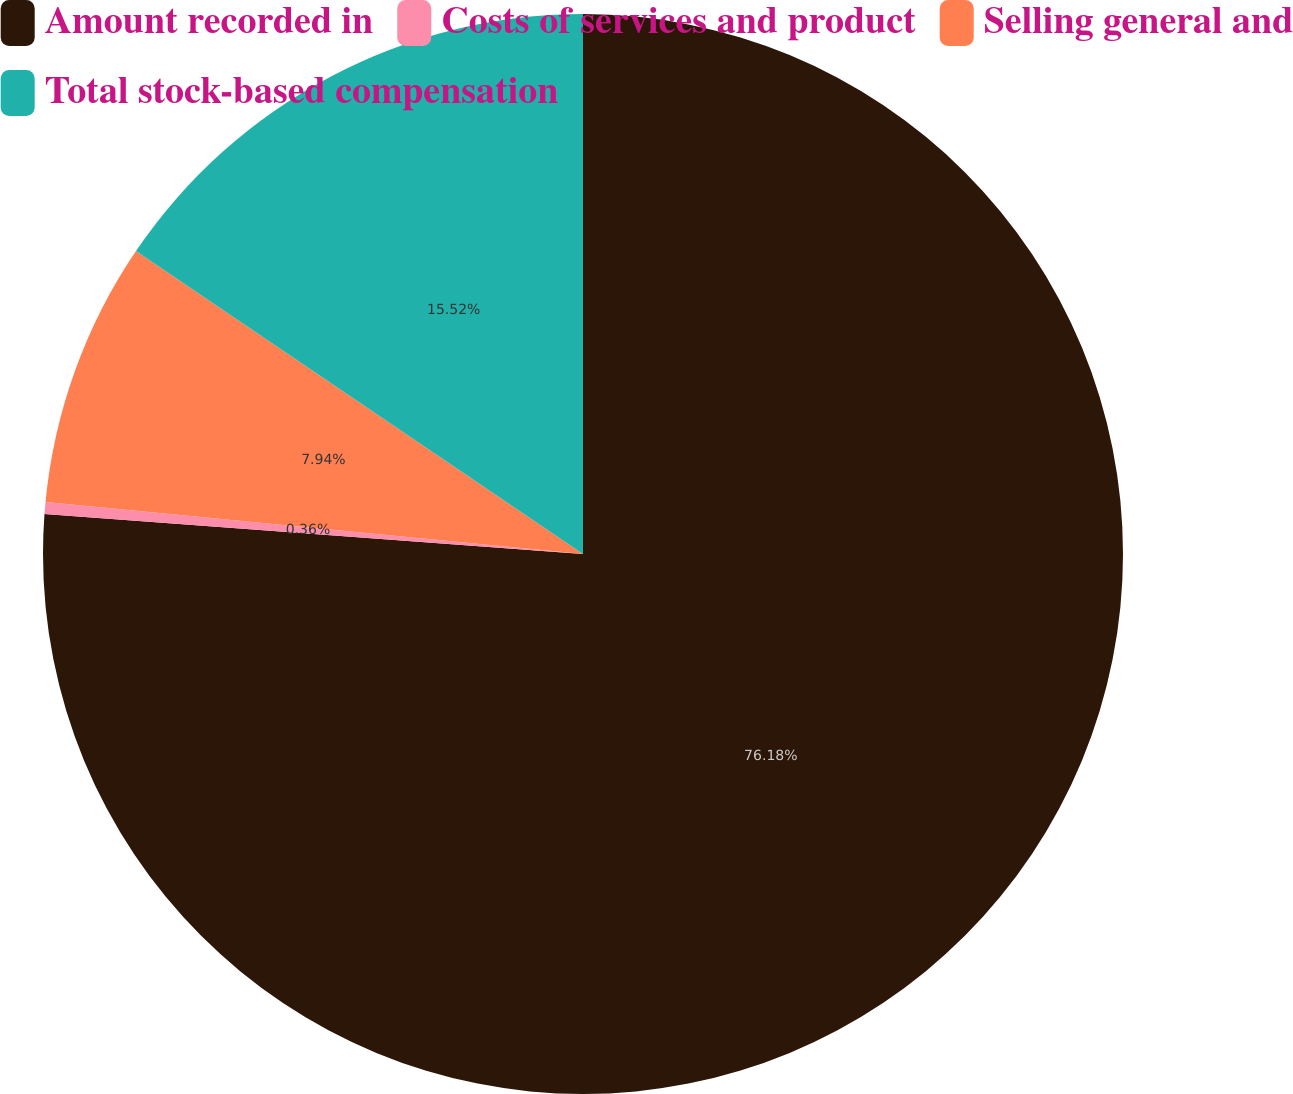Convert chart to OTSL. <chart><loc_0><loc_0><loc_500><loc_500><pie_chart><fcel>Amount recorded in<fcel>Costs of services and product<fcel>Selling general and<fcel>Total stock-based compensation<nl><fcel>76.17%<fcel>0.36%<fcel>7.94%<fcel>15.52%<nl></chart> 